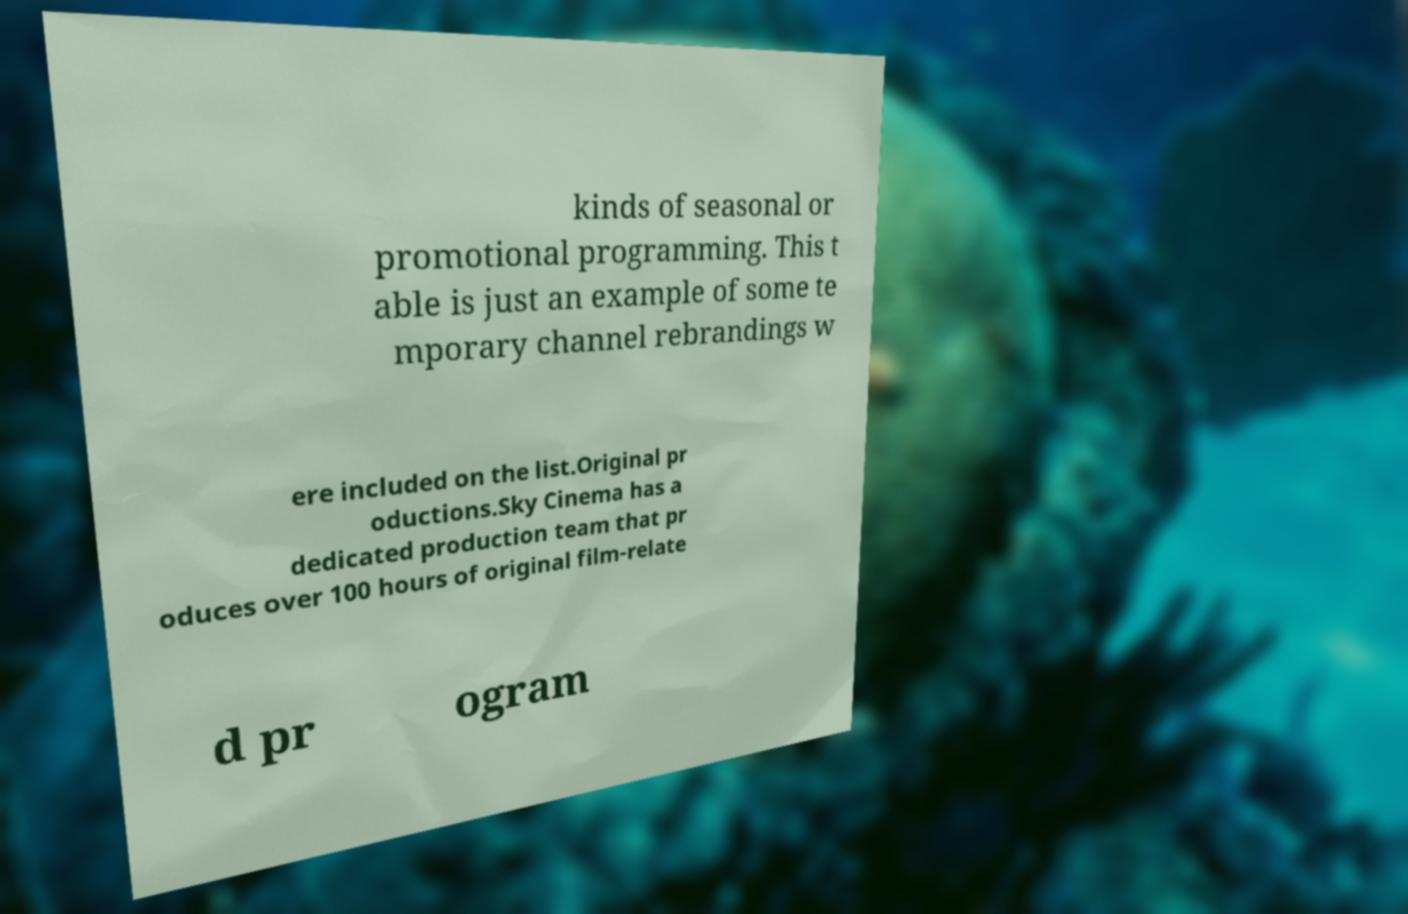There's text embedded in this image that I need extracted. Can you transcribe it verbatim? kinds of seasonal or promotional programming. This t able is just an example of some te mporary channel rebrandings w ere included on the list.Original pr oductions.Sky Cinema has a dedicated production team that pr oduces over 100 hours of original film-relate d pr ogram 